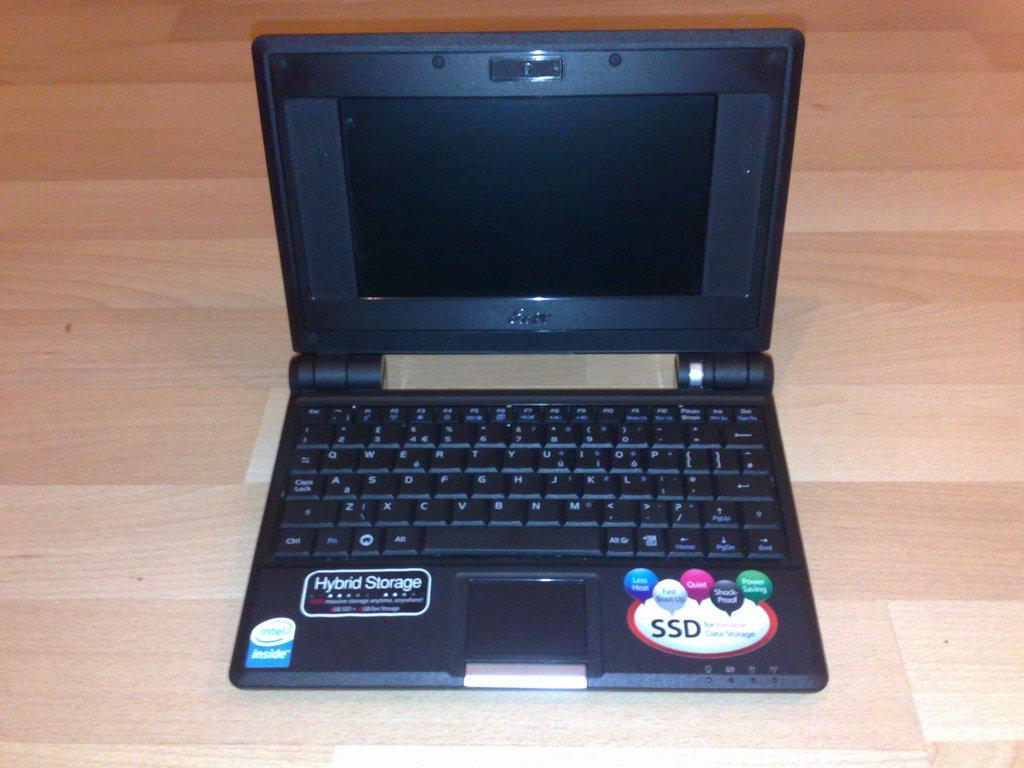<image>
Relay a brief, clear account of the picture shown. A laptop with hybrid storage from Intel sits on a wood surface. 